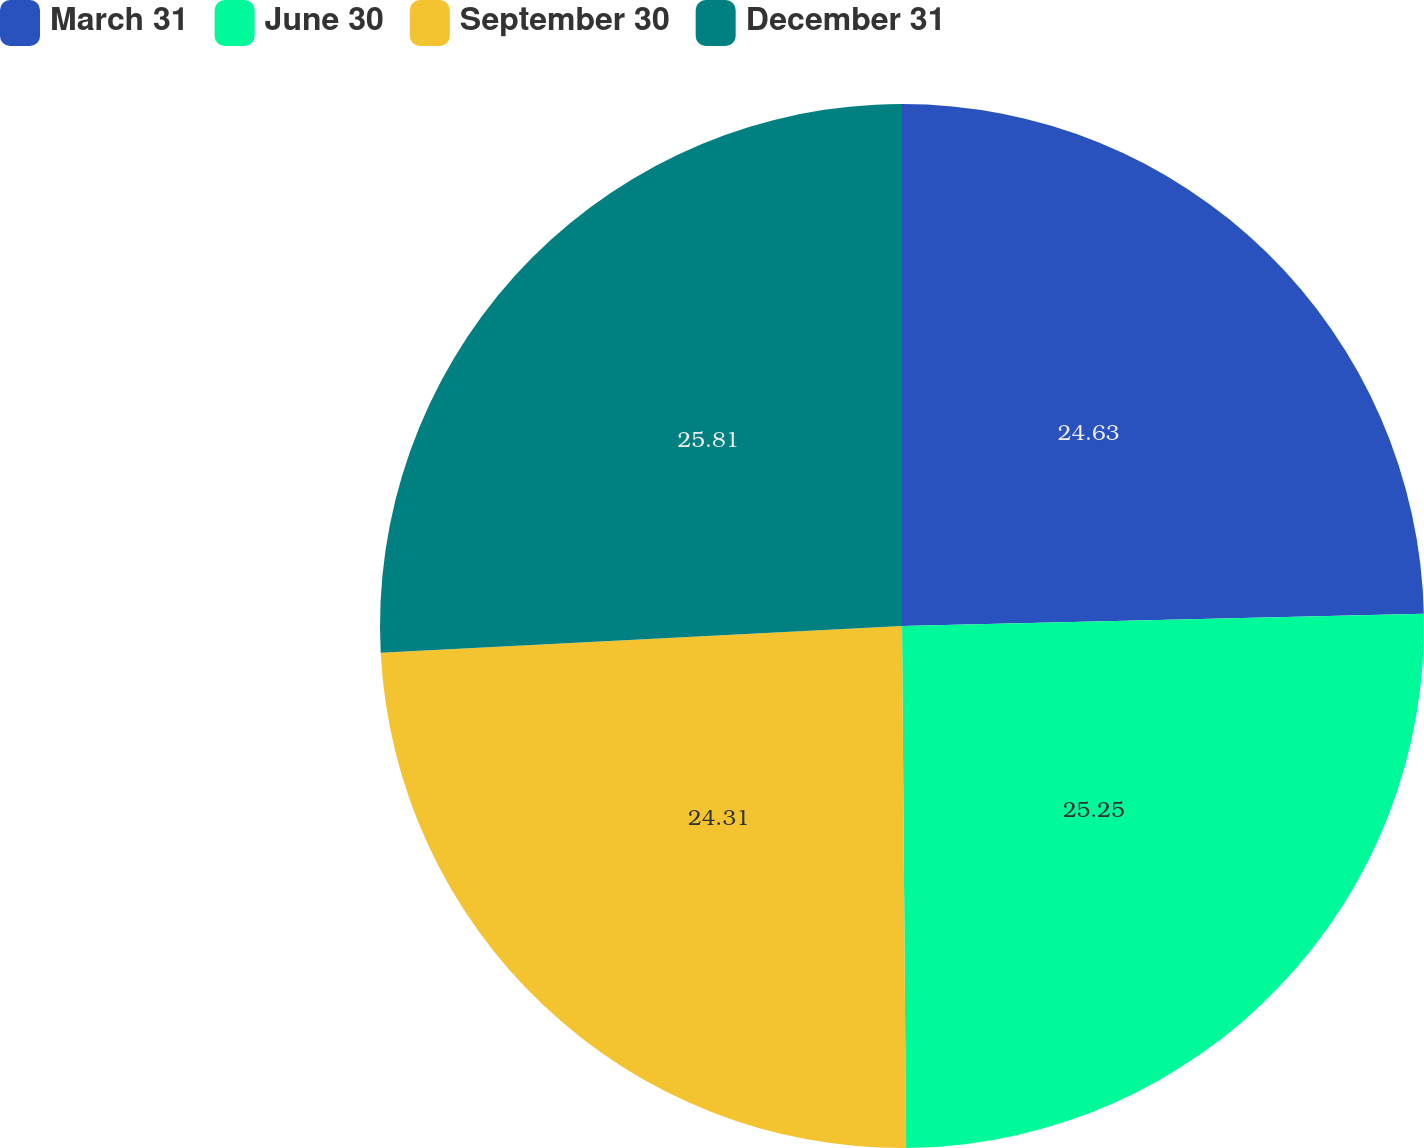Convert chart to OTSL. <chart><loc_0><loc_0><loc_500><loc_500><pie_chart><fcel>March 31<fcel>June 30<fcel>September 30<fcel>December 31<nl><fcel>24.63%<fcel>25.25%<fcel>24.31%<fcel>25.82%<nl></chart> 